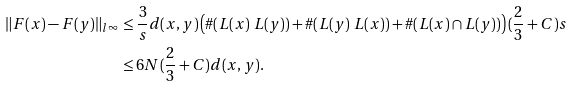Convert formula to latex. <formula><loc_0><loc_0><loc_500><loc_500>\| F ( x ) - F ( y ) \| _ { l ^ { \infty } } & \leq \frac { 3 } { s } d ( x , y ) \left ( \# ( L ( x ) \ L ( y ) ) + \# ( L ( y ) \ L ( x ) ) + \# ( L ( x ) \cap L ( y ) ) \right ) ( \frac { 2 } { 3 } + C ) s \\ & \leq 6 N ( \frac { 2 } { 3 } + C ) d ( x , y ) .</formula> 